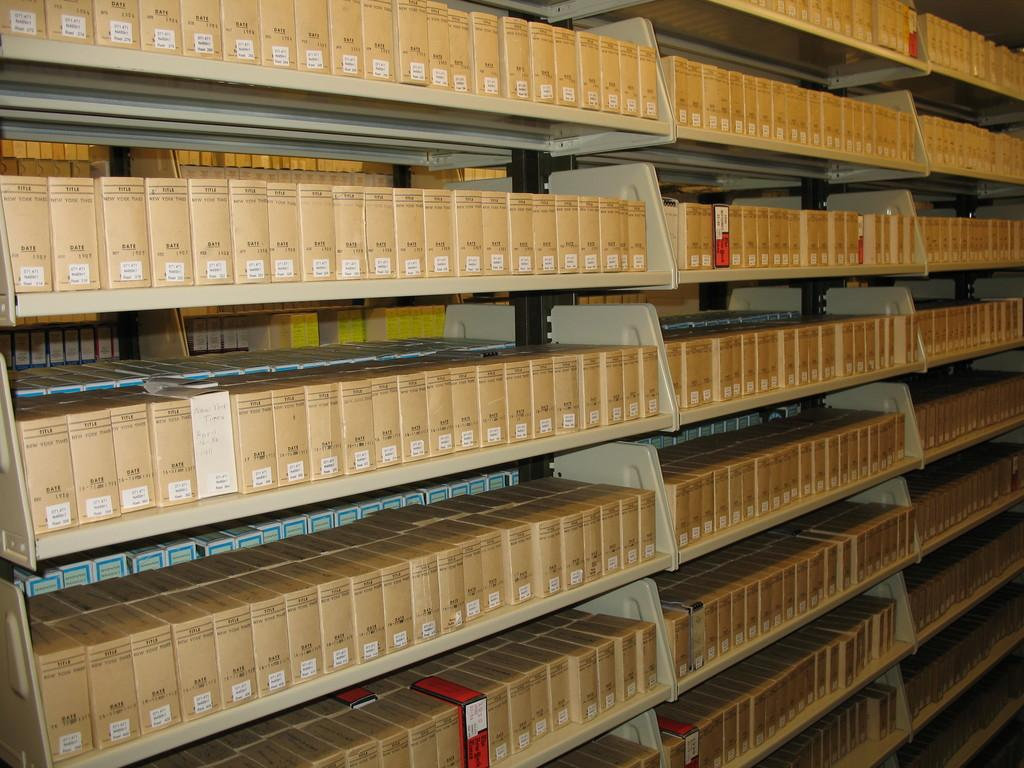What type of storage units are present in the image? There are cream-colored racks in the image. What are the racks holding? The racks are holding brown boxes. Are there any other colors of boxes visible? Yes, some boxes are red and white in color. Can you see the mom and cub interacting with the racks in the image? There is no mom or cub present in the image; it only features racks, brown boxes, and red and white boxes. 